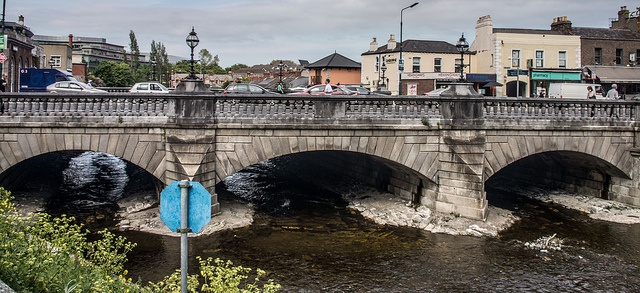Describe the objects in this image and their specific colors. I can see stop sign in darkgray and lightblue tones, truck in darkgray, navy, black, and gray tones, truck in darkgray, lightgray, and black tones, car in darkgray, lightgray, gray, and black tones, and car in darkgray, lightgray, lightpink, and gray tones in this image. 